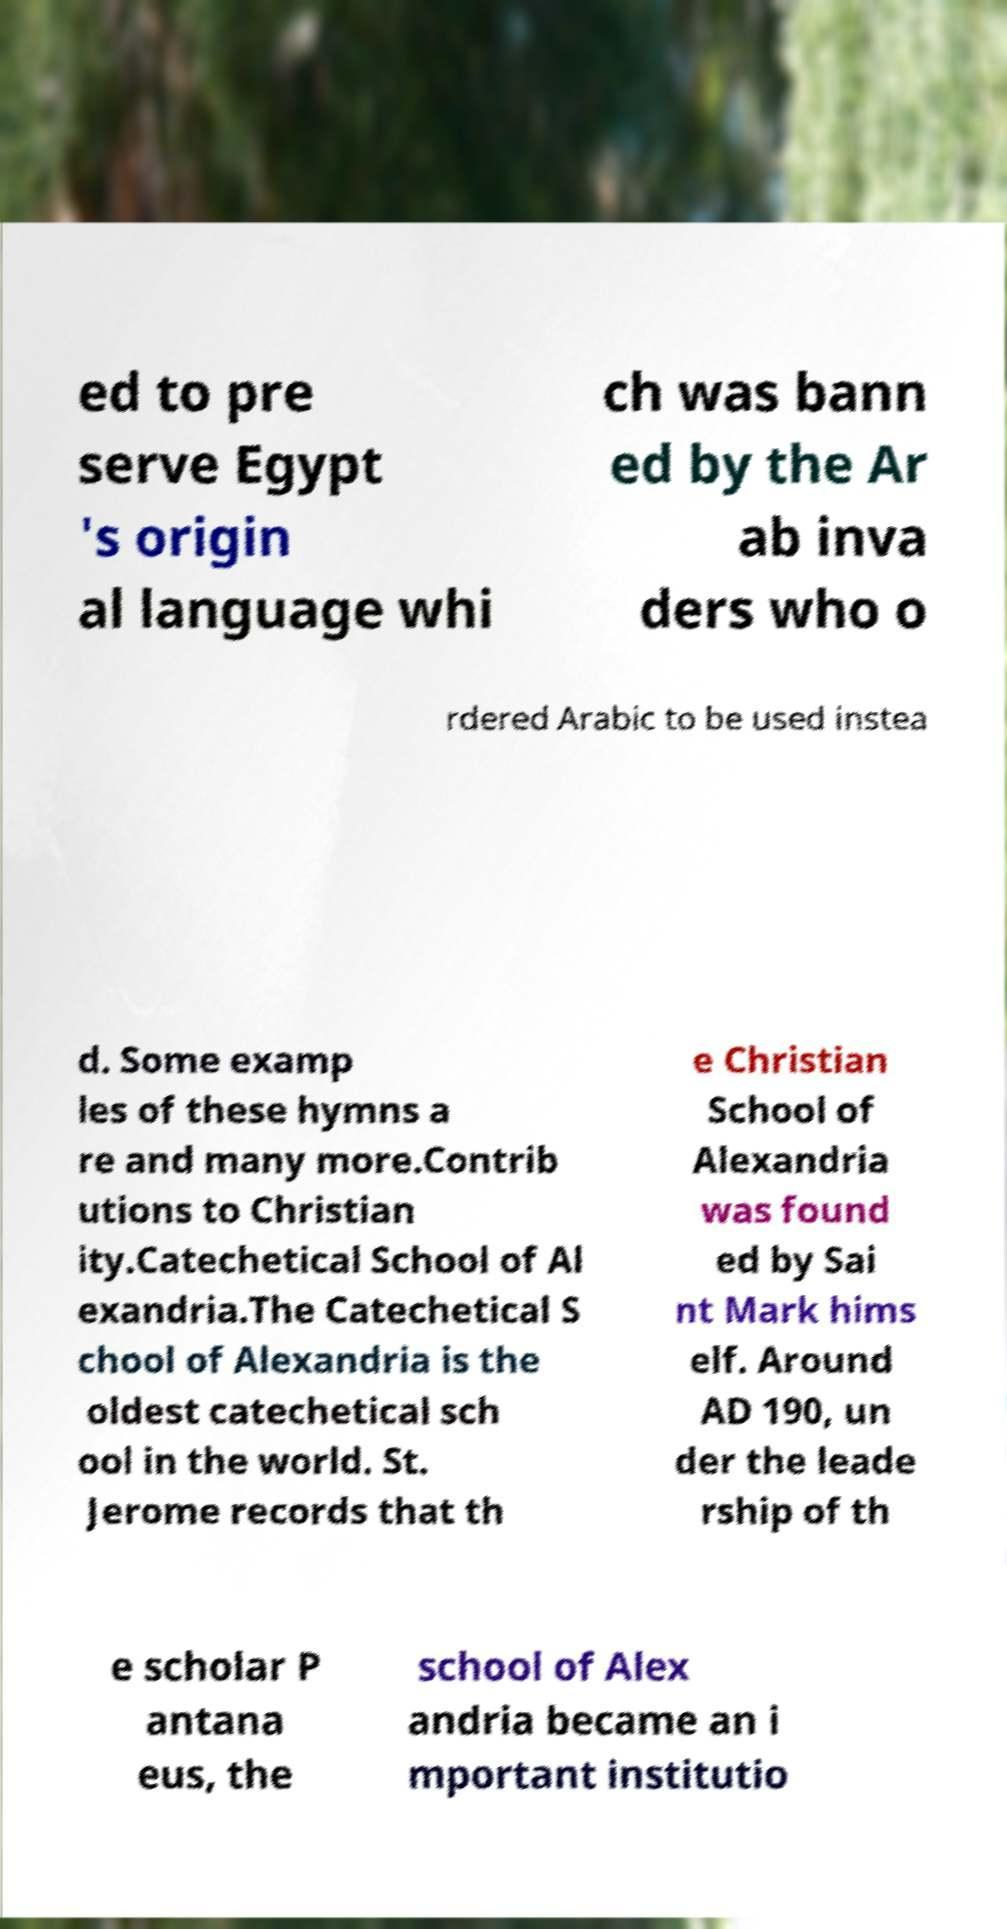For documentation purposes, I need the text within this image transcribed. Could you provide that? ed to pre serve Egypt 's origin al language whi ch was bann ed by the Ar ab inva ders who o rdered Arabic to be used instea d. Some examp les of these hymns a re and many more.Contrib utions to Christian ity.Catechetical School of Al exandria.The Catechetical S chool of Alexandria is the oldest catechetical sch ool in the world. St. Jerome records that th e Christian School of Alexandria was found ed by Sai nt Mark hims elf. Around AD 190, un der the leade rship of th e scholar P antana eus, the school of Alex andria became an i mportant institutio 